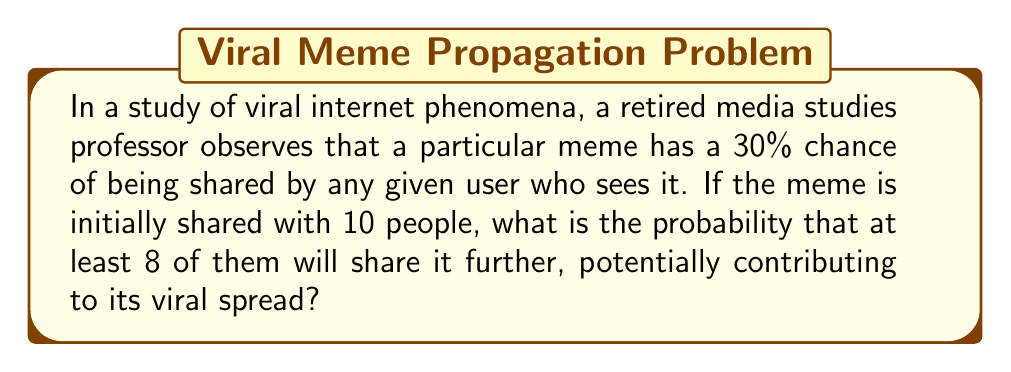Can you answer this question? To solve this problem, we need to use the binomial probability distribution, as we're dealing with a fixed number of independent trials (10 people) with a constant probability of success (30% chance of sharing).

Let $X$ be the random variable representing the number of people who share the meme.

We want to find $P(X \geq 8)$, which is equivalent to $1 - P(X \leq 7)$.

The probability mass function for a binomial distribution is:

$$P(X = k) = \binom{n}{k} p^k (1-p)^{n-k}$$

Where:
$n$ = number of trials (10 people)
$k$ = number of successes
$p$ = probability of success (0.30)

We need to calculate:

$$P(X \geq 8) = 1 - [P(X = 0) + P(X = 1) + P(X = 2) + P(X = 3) + P(X = 4) + P(X = 5) + P(X = 6) + P(X = 7)]$$

Let's calculate each term:

$$P(X = 0) = \binom{10}{0} (0.30)^0 (0.70)^{10} \approx 0.0282$$
$$P(X = 1) = \binom{10}{1} (0.30)^1 (0.70)^9 \approx 0.1211$$
$$P(X = 2) = \binom{10}{2} (0.30)^2 (0.70)^8 \approx 0.2335$$
$$P(X = 3) = \binom{10}{3} (0.30)^3 (0.70)^7 \approx 0.2668$$
$$P(X = 4) = \binom{10}{4} (0.30)^4 (0.70)^6 \approx 0.2001$$
$$P(X = 5) = \binom{10}{5} (0.30)^5 (0.70)^5 \approx 0.1029$$
$$P(X = 6) = \binom{10}{6} (0.30)^6 (0.70)^4 \approx 0.0368$$
$$P(X = 7) = \binom{10}{7} (0.30)^7 (0.70)^3 \approx 0.0090$$

Sum these probabilities:
$$0.0282 + 0.1211 + 0.2335 + 0.2668 + 0.2001 + 0.1029 + 0.0368 + 0.0090 = 0.9984$$

Therefore, $P(X \geq 8) = 1 - 0.9984 = 0.0016$
Answer: The probability that at least 8 out of 10 people will share the meme is approximately 0.0016 or 0.16%. 